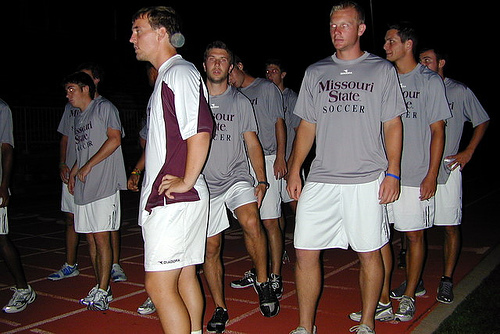<image>
Is the guy in front of the other guy? Yes. The guy is positioned in front of the other guy, appearing closer to the camera viewpoint. 